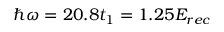Convert formula to latex. <formula><loc_0><loc_0><loc_500><loc_500>\hbar { \omega } = 2 0 . 8 t _ { 1 } = 1 . 2 5 E _ { r e c }</formula> 